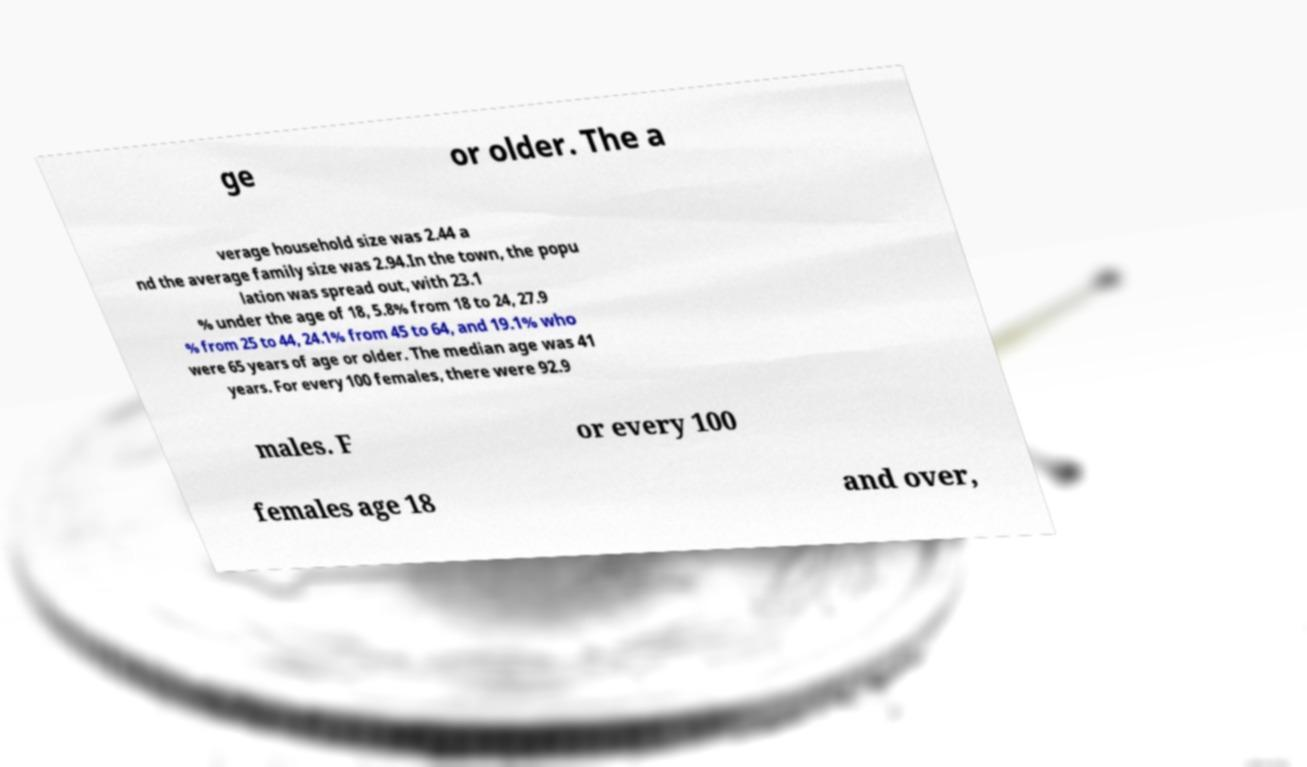Could you assist in decoding the text presented in this image and type it out clearly? ge or older. The a verage household size was 2.44 a nd the average family size was 2.94.In the town, the popu lation was spread out, with 23.1 % under the age of 18, 5.8% from 18 to 24, 27.9 % from 25 to 44, 24.1% from 45 to 64, and 19.1% who were 65 years of age or older. The median age was 41 years. For every 100 females, there were 92.9 males. F or every 100 females age 18 and over, 